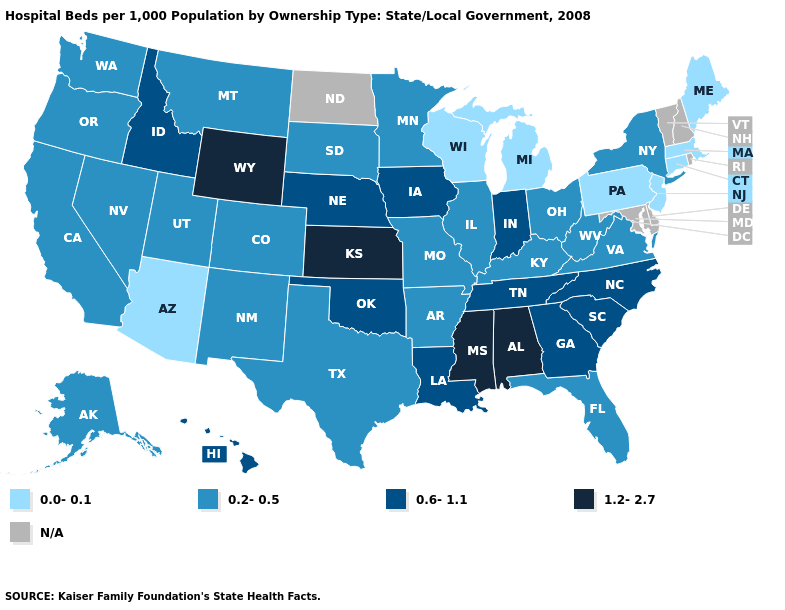How many symbols are there in the legend?
Answer briefly. 5. Which states have the lowest value in the USA?
Concise answer only. Arizona, Connecticut, Maine, Massachusetts, Michigan, New Jersey, Pennsylvania, Wisconsin. Name the states that have a value in the range N/A?
Answer briefly. Delaware, Maryland, New Hampshire, North Dakota, Rhode Island, Vermont. Among the states that border Oklahoma , does Arkansas have the lowest value?
Be succinct. Yes. Name the states that have a value in the range 1.2-2.7?
Concise answer only. Alabama, Kansas, Mississippi, Wyoming. Which states hav the highest value in the MidWest?
Answer briefly. Kansas. Which states hav the highest value in the Northeast?
Be succinct. New York. What is the lowest value in the West?
Give a very brief answer. 0.0-0.1. Name the states that have a value in the range 0.0-0.1?
Give a very brief answer. Arizona, Connecticut, Maine, Massachusetts, Michigan, New Jersey, Pennsylvania, Wisconsin. What is the value of Missouri?
Write a very short answer. 0.2-0.5. Among the states that border Oklahoma , which have the highest value?
Keep it brief. Kansas. Which states have the lowest value in the MidWest?
Write a very short answer. Michigan, Wisconsin. 